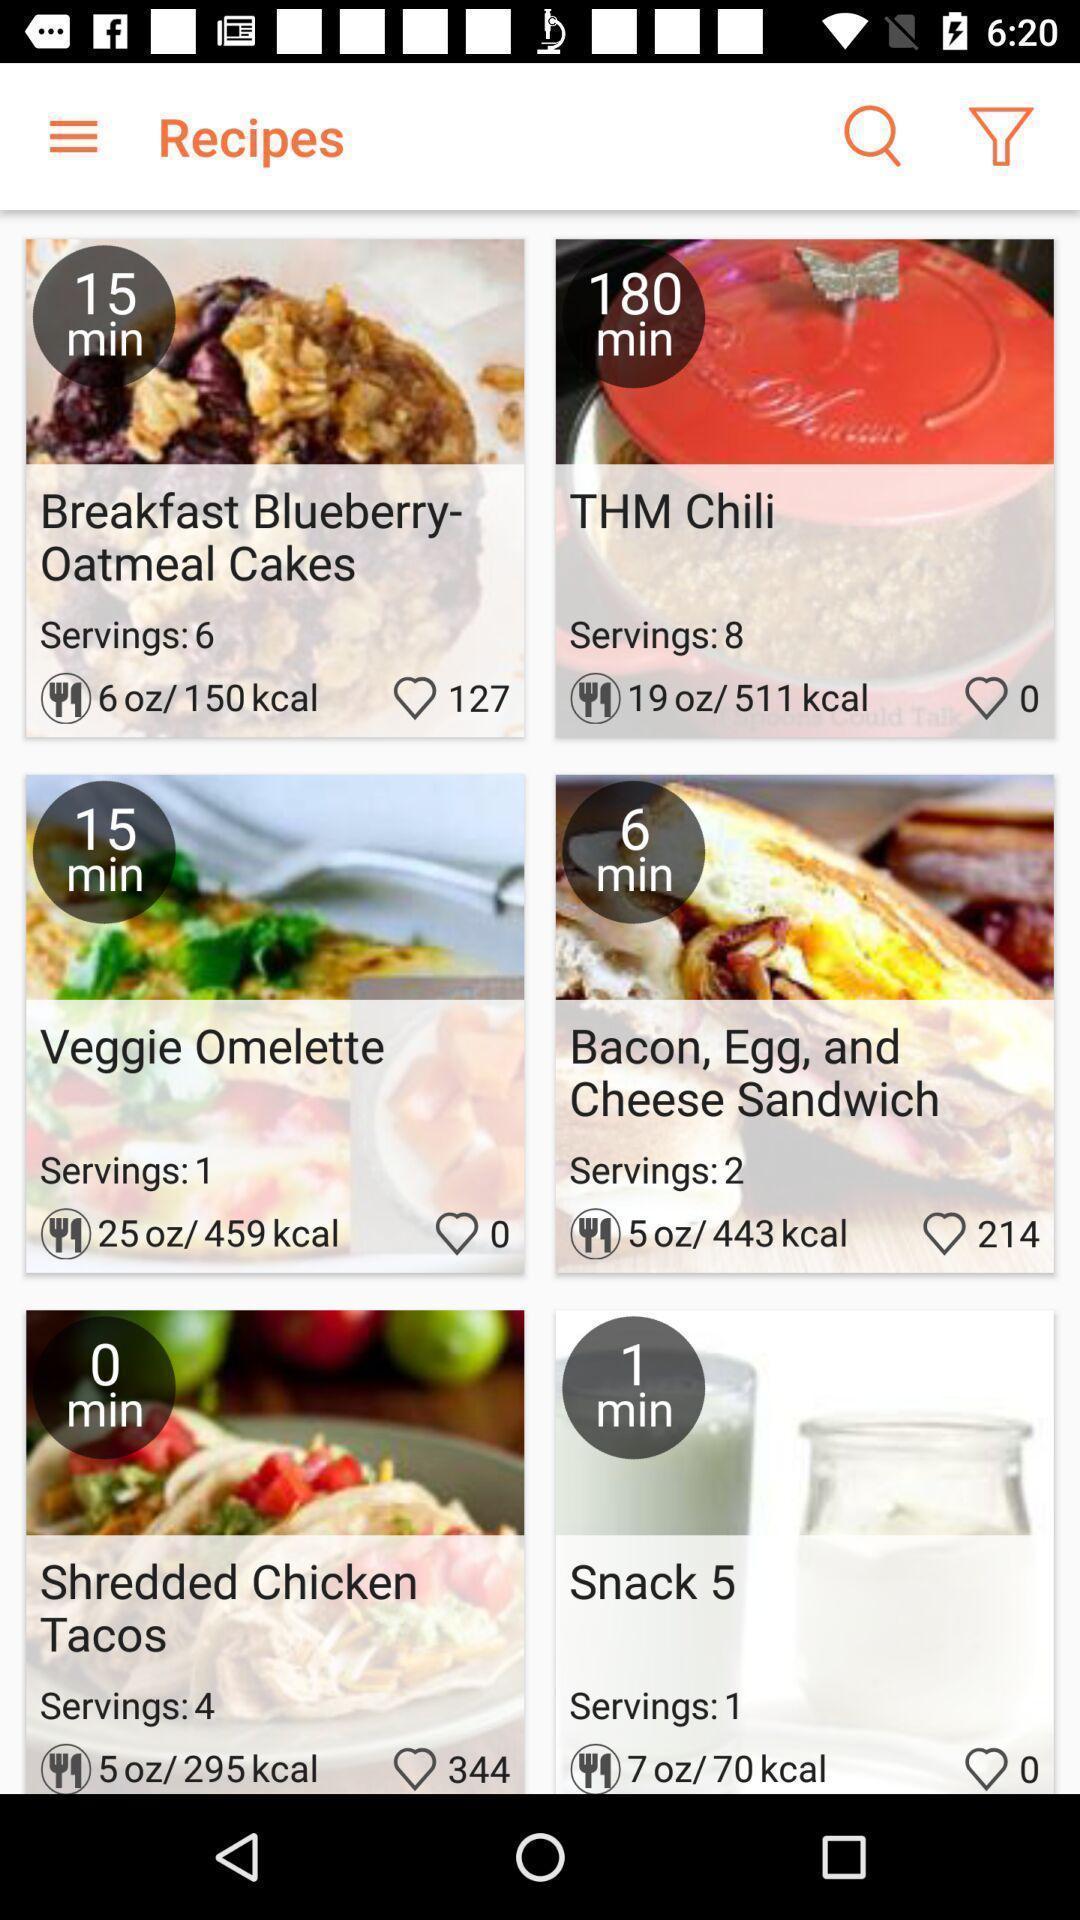Give me a narrative description of this picture. Screen displaying the recipes page. 